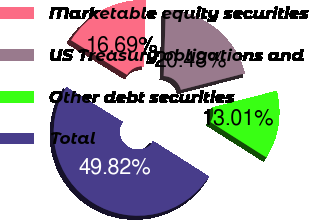Convert chart to OTSL. <chart><loc_0><loc_0><loc_500><loc_500><pie_chart><fcel>Marketable equity securities<fcel>US Treasury obligations and<fcel>Other debt securities<fcel>Total<nl><fcel>16.69%<fcel>20.48%<fcel>13.01%<fcel>49.82%<nl></chart> 